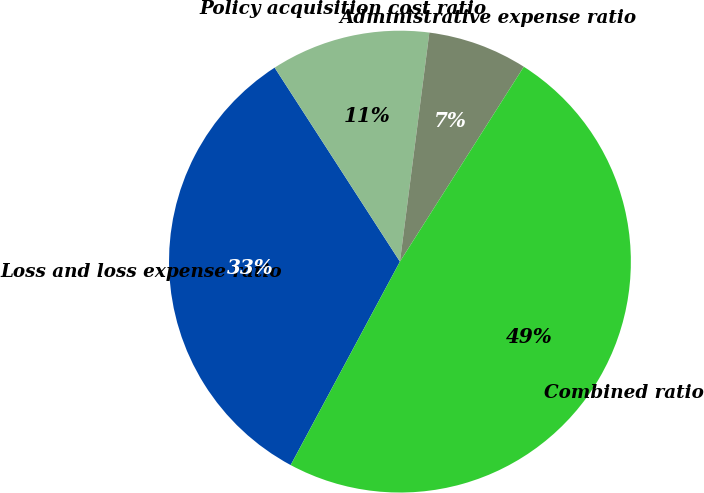<chart> <loc_0><loc_0><loc_500><loc_500><pie_chart><fcel>Loss and loss expense ratio<fcel>Policy acquisition cost ratio<fcel>Administrative expense ratio<fcel>Combined ratio<nl><fcel>33.03%<fcel>11.16%<fcel>6.98%<fcel>48.83%<nl></chart> 